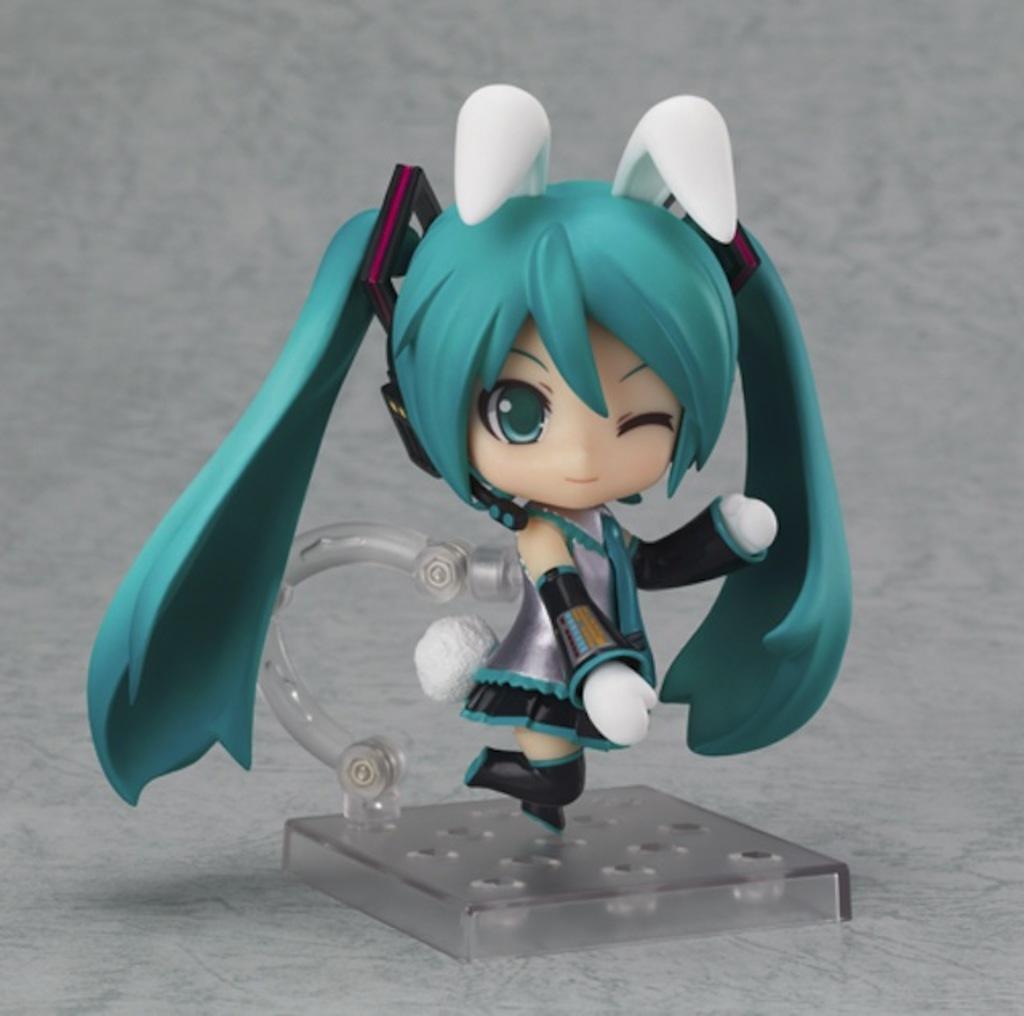In one or two sentences, can you explain what this image depicts? In this image we can see a toy placed on the surface. 